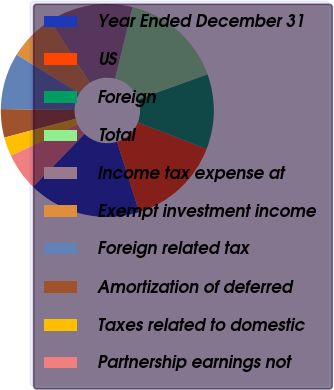<chart> <loc_0><loc_0><loc_500><loc_500><pie_chart><fcel>Year Ended December 31<fcel>US<fcel>Foreign<fcel>Total<fcel>Income tax expense at<fcel>Exempt investment income<fcel>Foreign related tax<fcel>Amortization of deferred<fcel>Taxes related to domestic<fcel>Partnership earnings not<nl><fcel>17.11%<fcel>14.27%<fcel>11.42%<fcel>15.69%<fcel>12.84%<fcel>7.16%<fcel>8.58%<fcel>4.31%<fcel>2.89%<fcel>5.73%<nl></chart> 